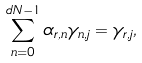Convert formula to latex. <formula><loc_0><loc_0><loc_500><loc_500>\sum _ { n = 0 } ^ { d N - 1 } \alpha _ { r , n } \gamma _ { n , j } = \gamma _ { r , j } ,</formula> 